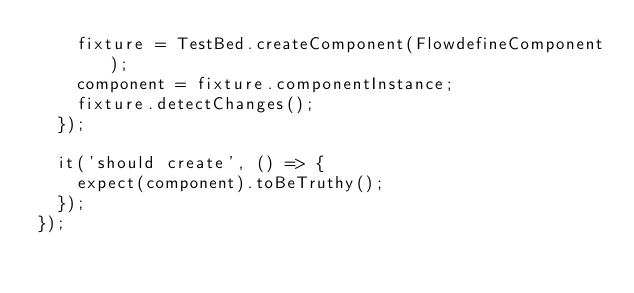<code> <loc_0><loc_0><loc_500><loc_500><_TypeScript_>    fixture = TestBed.createComponent(FlowdefineComponent);
    component = fixture.componentInstance;
    fixture.detectChanges();
  });

  it('should create', () => {
    expect(component).toBeTruthy();
  });
});
</code> 